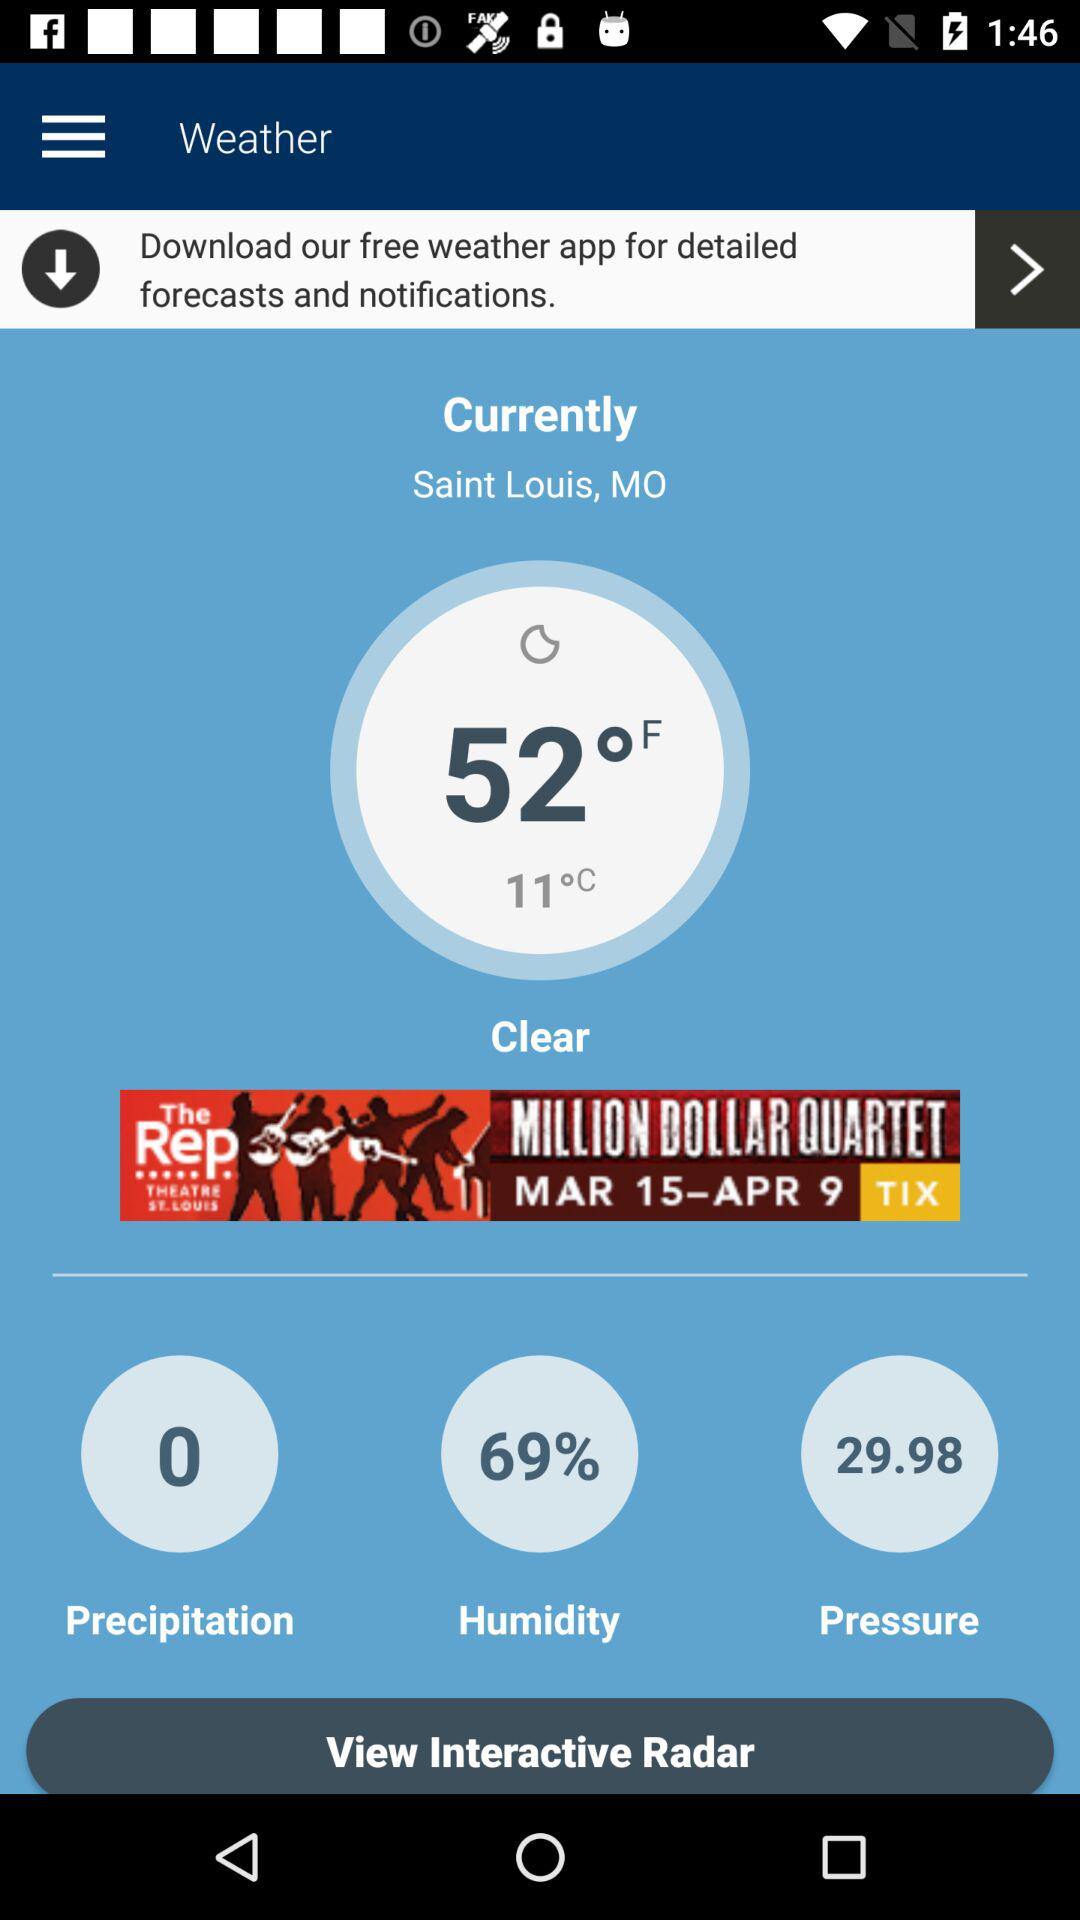What is the weather on Sunday?
When the provided information is insufficient, respond with <no answer>. <no answer> 